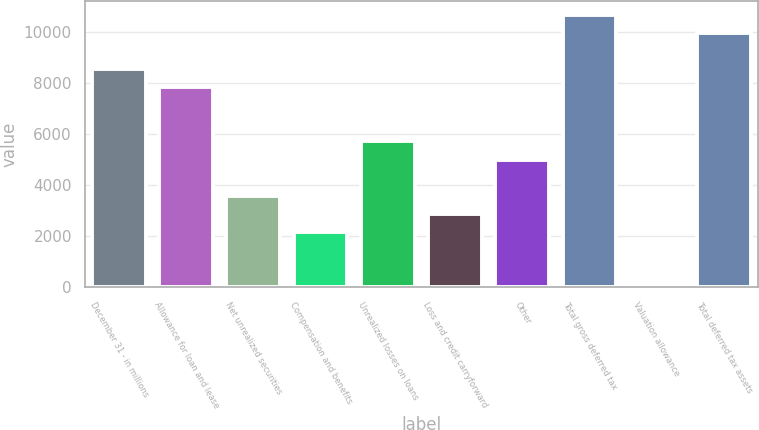Convert chart. <chart><loc_0><loc_0><loc_500><loc_500><bar_chart><fcel>December 31 - in millions<fcel>Allowance for loan and lease<fcel>Net unrealized securities<fcel>Compensation and benefits<fcel>Unrealized losses on loans<fcel>Loss and credit carryforward<fcel>Other<fcel>Total gross deferred tax<fcel>Valuation allowance<fcel>Total deferred tax assets<nl><fcel>8561.8<fcel>7850.9<fcel>3585.5<fcel>2163.7<fcel>5718.2<fcel>2874.6<fcel>5007.3<fcel>10694.5<fcel>31<fcel>9983.6<nl></chart> 